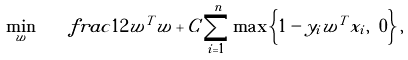Convert formula to latex. <formula><loc_0><loc_0><loc_500><loc_500>\min _ { w } \quad f r a c { 1 } { 2 } w ^ { T } w + C \sum _ { i = 1 } ^ { n } \max \left \{ 1 - y _ { i } w ^ { T } x _ { i } , \ 0 \right \} ,</formula> 